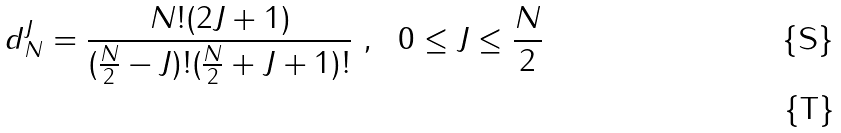Convert formula to latex. <formula><loc_0><loc_0><loc_500><loc_500>d ^ { J } _ { N } = \frac { N ! ( 2 J + 1 ) } { ( \frac { N } { 2 } - J ) ! ( \frac { N } { 2 } + J + 1 ) ! } \ , \ \ 0 \leq J \leq \frac { N } { 2 } \\</formula> 